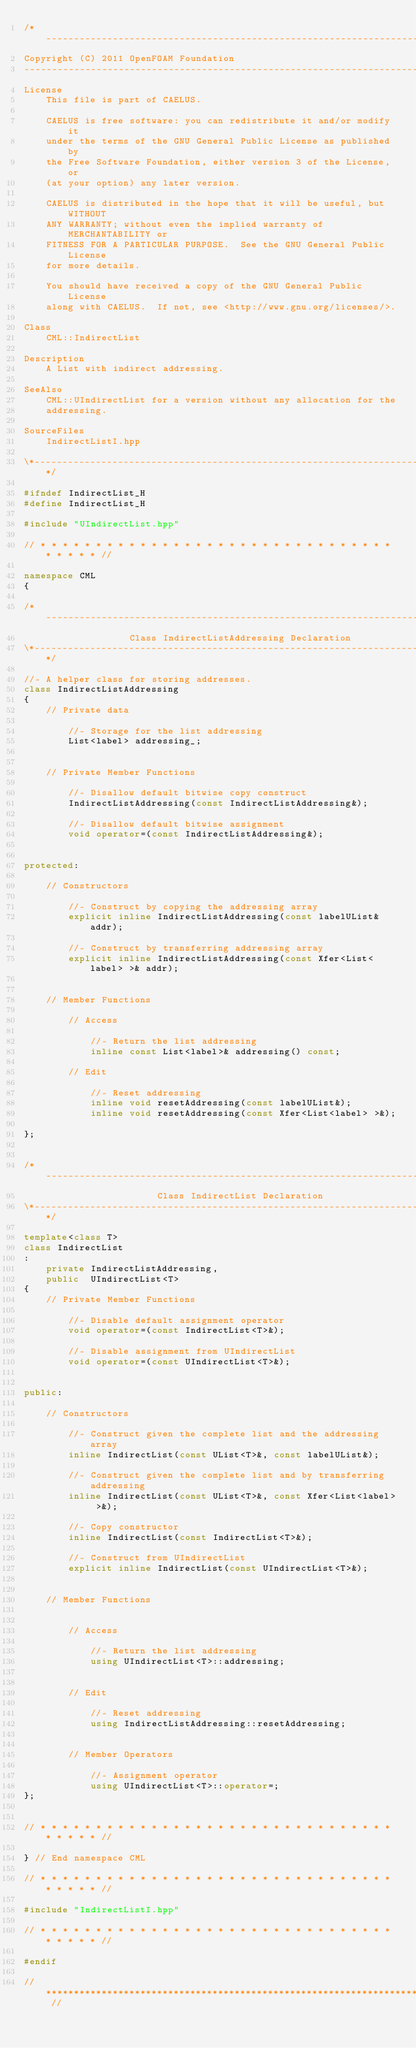Convert code to text. <code><loc_0><loc_0><loc_500><loc_500><_C++_>/*---------------------------------------------------------------------------*\
Copyright (C) 2011 OpenFOAM Foundation
-------------------------------------------------------------------------------
License
    This file is part of CAELUS.

    CAELUS is free software: you can redistribute it and/or modify it
    under the terms of the GNU General Public License as published by
    the Free Software Foundation, either version 3 of the License, or
    (at your option) any later version.

    CAELUS is distributed in the hope that it will be useful, but WITHOUT
    ANY WARRANTY; without even the implied warranty of MERCHANTABILITY or
    FITNESS FOR A PARTICULAR PURPOSE.  See the GNU General Public License
    for more details.

    You should have received a copy of the GNU General Public License
    along with CAELUS.  If not, see <http://www.gnu.org/licenses/>.

Class
    CML::IndirectList

Description
    A List with indirect addressing.

SeeAlso
    CML::UIndirectList for a version without any allocation for the
    addressing.

SourceFiles
    IndirectListI.hpp

\*---------------------------------------------------------------------------*/

#ifndef IndirectList_H
#define IndirectList_H

#include "UIndirectList.hpp"

// * * * * * * * * * * * * * * * * * * * * * * * * * * * * * * * * * * * * * //

namespace CML
{

/*---------------------------------------------------------------------------*\
                   Class IndirectListAddressing Declaration
\*---------------------------------------------------------------------------*/

//- A helper class for storing addresses.
class IndirectListAddressing
{
    // Private data

        //- Storage for the list addressing
        List<label> addressing_;


    // Private Member Functions

        //- Disallow default bitwise copy construct
        IndirectListAddressing(const IndirectListAddressing&);

        //- Disallow default bitwise assignment
        void operator=(const IndirectListAddressing&);


protected:

    // Constructors

        //- Construct by copying the addressing array
        explicit inline IndirectListAddressing(const labelUList& addr);

        //- Construct by transferring addressing array
        explicit inline IndirectListAddressing(const Xfer<List<label> >& addr);


    // Member Functions

        // Access

            //- Return the list addressing
            inline const List<label>& addressing() const;

        // Edit

            //- Reset addressing
            inline void resetAddressing(const labelUList&);
            inline void resetAddressing(const Xfer<List<label> >&);

};


/*---------------------------------------------------------------------------*\
                        Class IndirectList Declaration
\*---------------------------------------------------------------------------*/

template<class T>
class IndirectList
:
    private IndirectListAddressing,
    public  UIndirectList<T>
{
    // Private Member Functions

        //- Disable default assignment operator
        void operator=(const IndirectList<T>&);

        //- Disable assignment from UIndirectList
        void operator=(const UIndirectList<T>&);


public:

    // Constructors

        //- Construct given the complete list and the addressing array
        inline IndirectList(const UList<T>&, const labelUList&);

        //- Construct given the complete list and by transferring addressing
        inline IndirectList(const UList<T>&, const Xfer<List<label> >&);

        //- Copy constructor
        inline IndirectList(const IndirectList<T>&);

        //- Construct from UIndirectList
        explicit inline IndirectList(const UIndirectList<T>&);


    // Member Functions


        // Access

            //- Return the list addressing
            using UIndirectList<T>::addressing;


        // Edit

            //- Reset addressing
            using IndirectListAddressing::resetAddressing;


        // Member Operators

            //- Assignment operator
            using UIndirectList<T>::operator=;
};


// * * * * * * * * * * * * * * * * * * * * * * * * * * * * * * * * * * * * * //

} // End namespace CML

// * * * * * * * * * * * * * * * * * * * * * * * * * * * * * * * * * * * * * //

#include "IndirectListI.hpp"

// * * * * * * * * * * * * * * * * * * * * * * * * * * * * * * * * * * * * * //

#endif

// ************************************************************************* //
</code> 